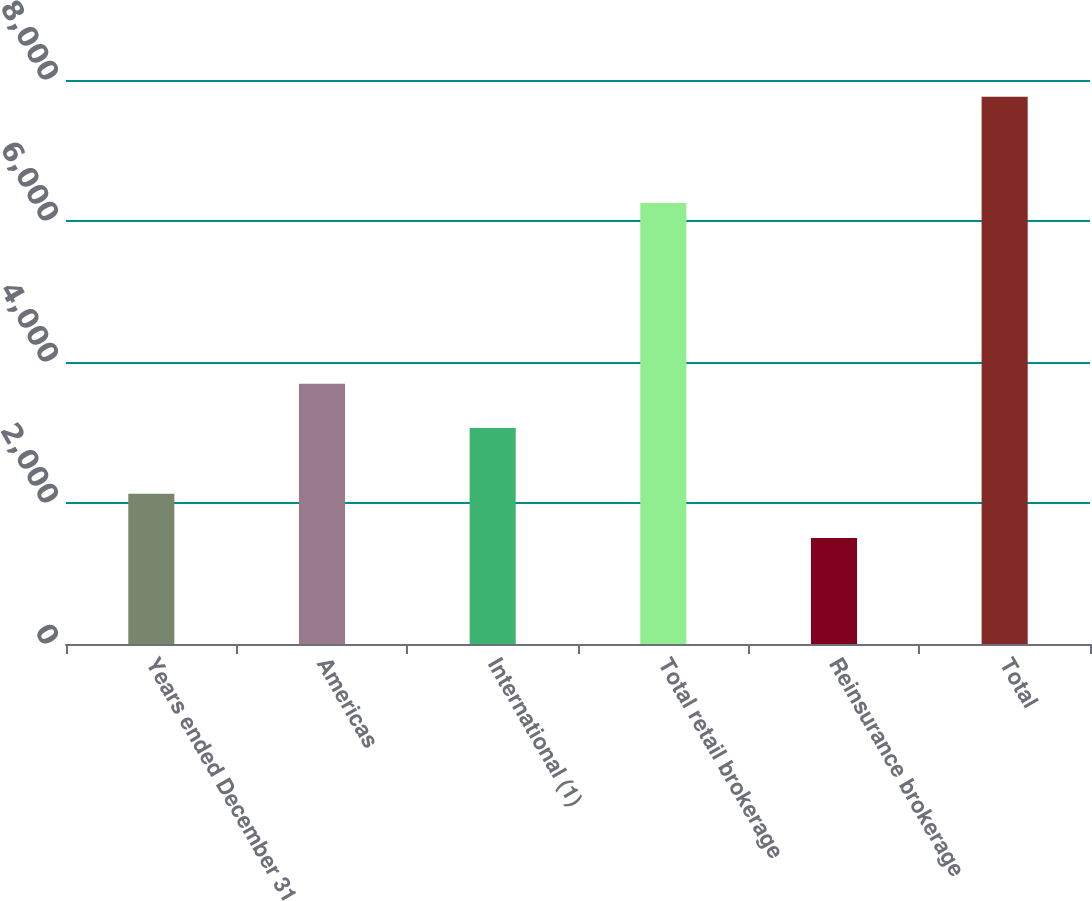<chart> <loc_0><loc_0><loc_500><loc_500><bar_chart><fcel>Years ended December 31<fcel>Americas<fcel>International (1)<fcel>Total retail brokerage<fcel>Reinsurance brokerage<fcel>Total<nl><fcel>2130.6<fcel>3690.6<fcel>3065<fcel>6256<fcel>1505<fcel>7761<nl></chart> 